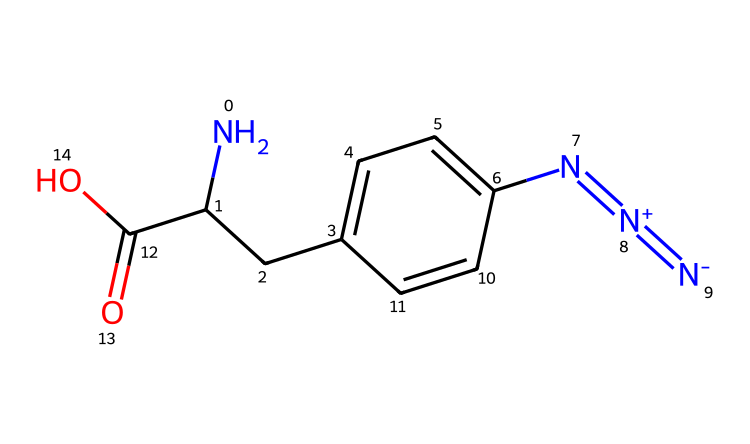How many carbon atoms are present in 4-azidophenylalanine? By examining the SMILES representation, we can identify the carbon atoms in both of the phenyl ring and the aliphatic chain. The phenyl ring has 6 carbon atoms, and there are 2 additional carbon atoms from the carbon chain (C(C1) and C(=O)), summing to 8.
Answer: 8 What functional group is present in the structure? A functional group is indicated in the structure as a carboxylic acid (-COOH), which can be seen from the C(=O)O part of the SMILES. This functional group typically gives the molecule acidic properties.
Answer: carboxylic acid How many nitrogen atoms are in 4-azidophenylalanine? In the SMILES representation, there are two nitrogen atoms in the azide group (N=[N+]=[N-]) and one nitrogen atom from the amine group (NC). Adding these gives a total of three nitrogen atoms.
Answer: 3 What type of chemical is 4-azidophenylalanine? The presence of the azide group indicates that this compound is an azide, which is characterized by the N=[N+]=[N-] structure, commonly used in various chemical applications including protein engineering.
Answer: azide Which part of the molecule is hydrophilic? The carboxylic acid group (-COOH) is typically hydrophilic due to the presence of polar -OH and -C(=O) groups that can form hydrogen bonds with water. This characteristic suggests better solubility in aqueous environments.
Answer: carboxylic acid group What role does the azide group play in protein engineering? The azide group serves as a functional handle for click chemistry reactions, allowing for the selective labeling or modification of biomolecules in bioinformatics applications, making it a valuable tool in protein engineering.
Answer: functional handle for click chemistry 